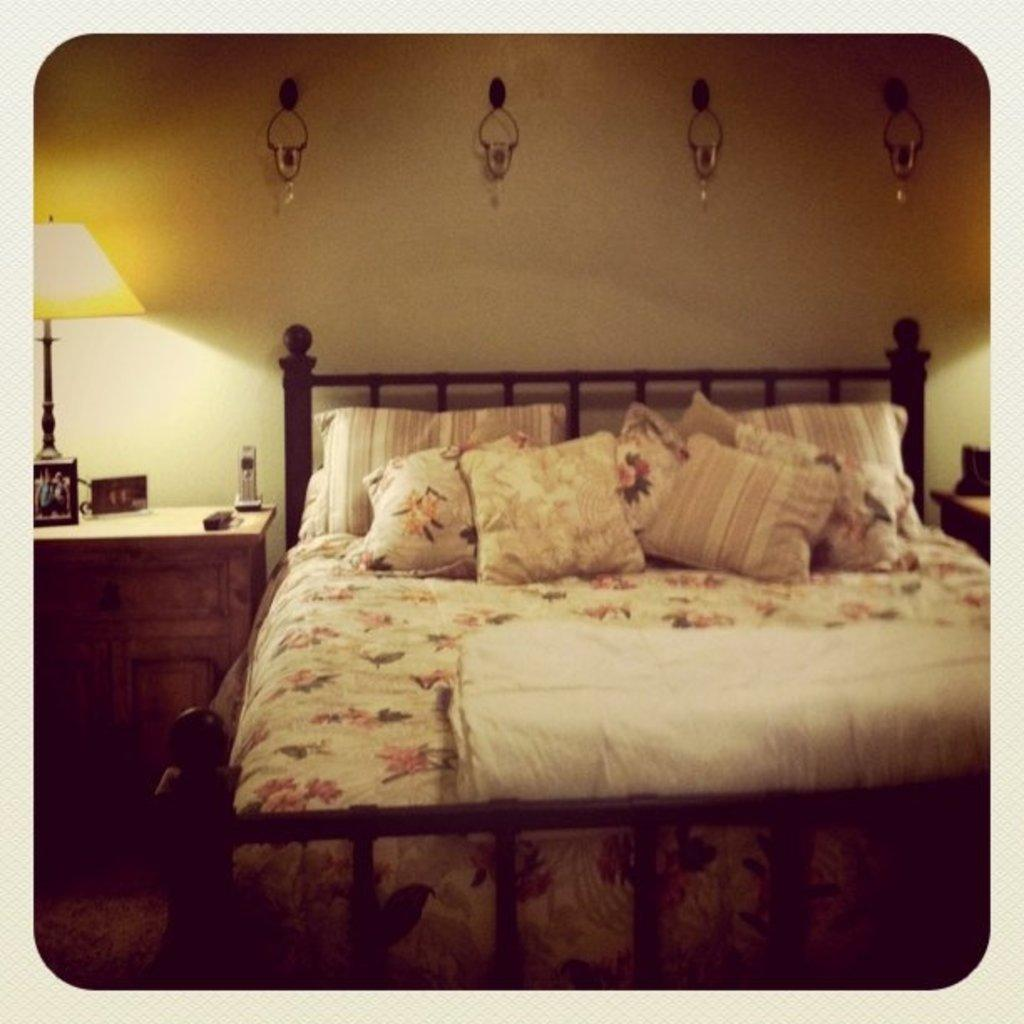What type of furniture is in the image? There is a bed in the image. What is placed on the bed? There are pillows on the bed. Where is the lamp located in the image? The lamp is on the left side of the image. What can be seen at the top of the image? There are hangers at the top of the image. Can you see a bee buzzing around the lamp in the image? There is no bee present in the image; it only features a bed, pillows, a lamp, and hangers. Are there any berries on the bed? There are no berries visible in the image; it only features a bed, pillows, a lamp, and hangers. 